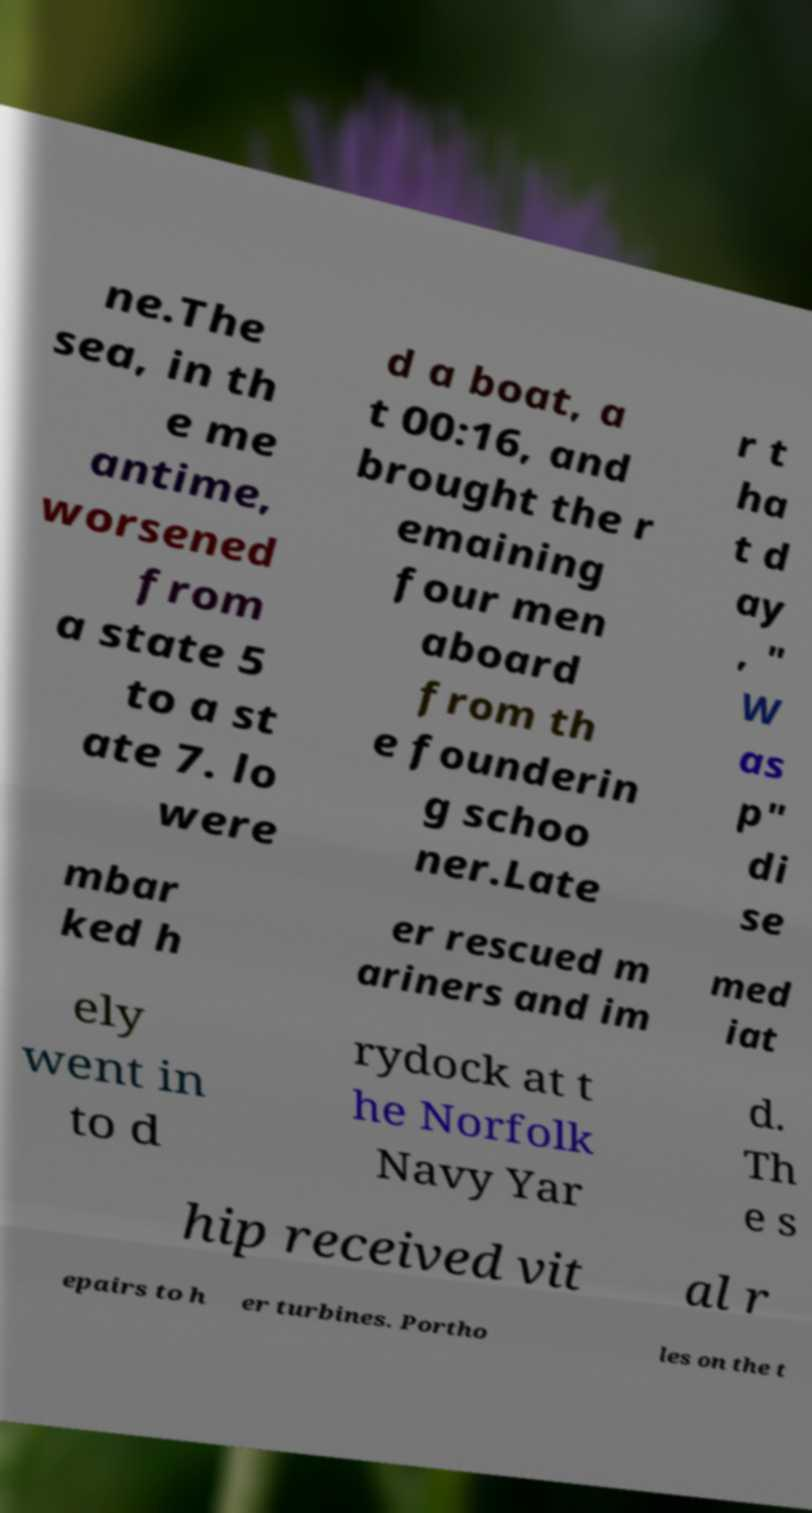There's text embedded in this image that I need extracted. Can you transcribe it verbatim? ne.The sea, in th e me antime, worsened from a state 5 to a st ate 7. lo were d a boat, a t 00:16, and brought the r emaining four men aboard from th e founderin g schoo ner.Late r t ha t d ay , " W as p" di se mbar ked h er rescued m ariners and im med iat ely went in to d rydock at t he Norfolk Navy Yar d. Th e s hip received vit al r epairs to h er turbines. Portho les on the t 